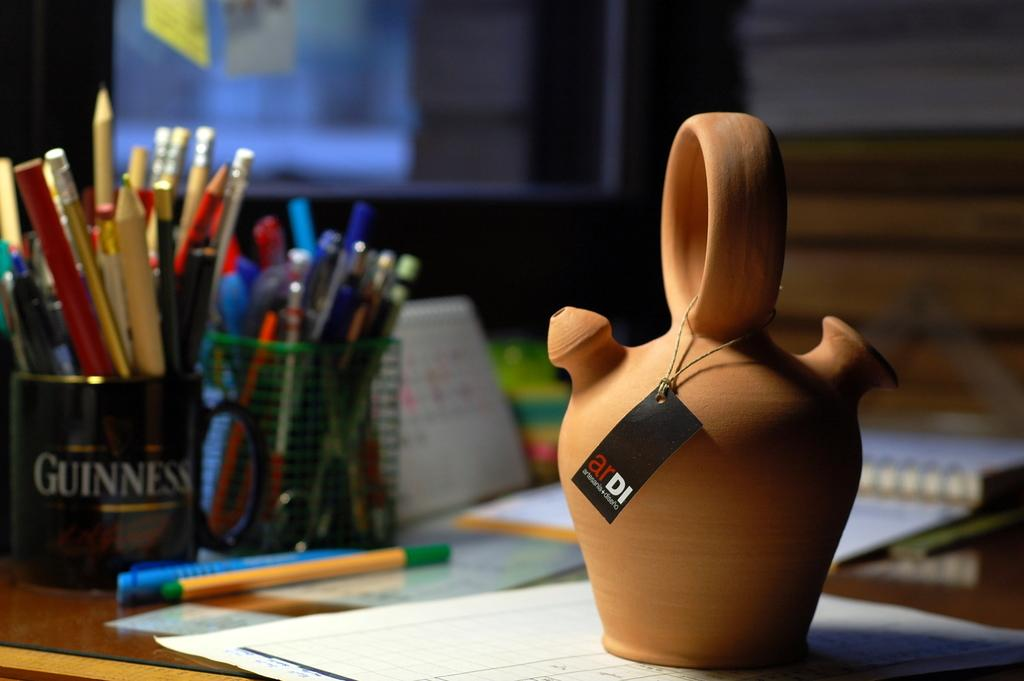<image>
Relay a brief, clear account of the picture shown. A clay pot on a desk in front of a Guinness mug full of pencils. 